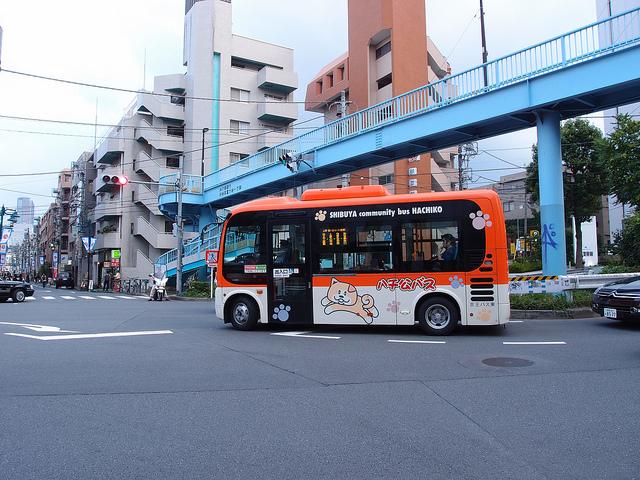Is this a double decker bus?
Keep it brief. No. What animal is on the transportation?
Concise answer only. Cat. What color are the street markings?
Answer briefly. White. 